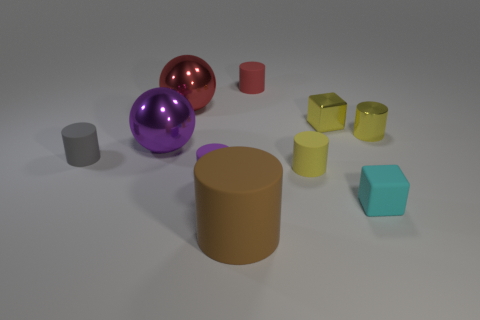What color is the tiny rubber cylinder that is both on the left side of the brown rubber thing and on the right side of the gray thing?
Give a very brief answer. Purple. What number of cubes are either small red metal objects or small metal things?
Ensure brevity in your answer.  1. Are there fewer gray rubber cylinders right of the tiny metallic cylinder than tiny yellow blocks?
Offer a terse response. Yes. There is a big brown object that is the same material as the gray cylinder; what is its shape?
Offer a very short reply. Cylinder. How many metal things are the same color as the large cylinder?
Your response must be concise. 0. What number of objects are large red metal balls or large matte cylinders?
Ensure brevity in your answer.  2. There is a cylinder that is to the right of the block behind the tiny purple matte cylinder; what is its material?
Provide a short and direct response. Metal. Is there a cylinder made of the same material as the brown object?
Make the answer very short. Yes. There is a metallic thing that is left of the red thing that is in front of the red thing right of the large brown rubber object; what is its shape?
Provide a short and direct response. Sphere. What is the material of the yellow cube?
Offer a terse response. Metal. 